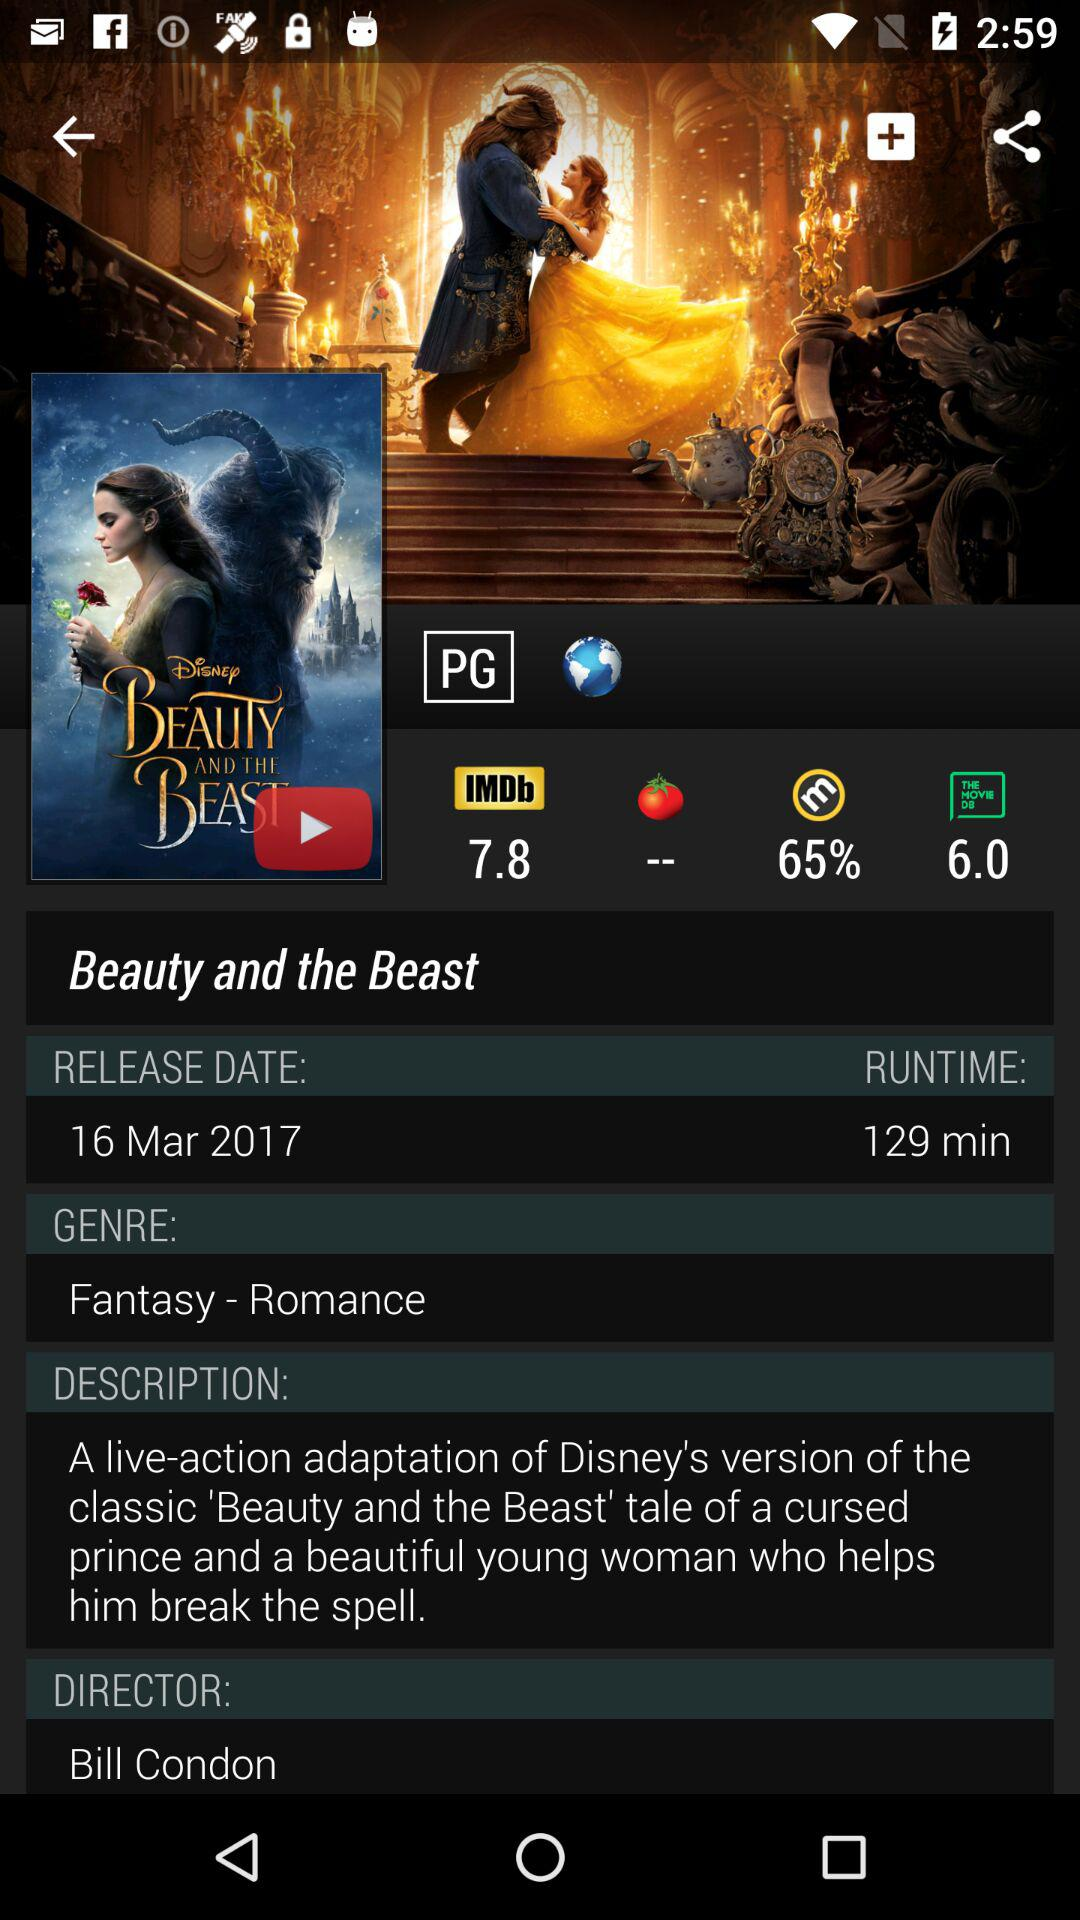Who is the director of Beauty and the Beast? The director is Bill Condon. 